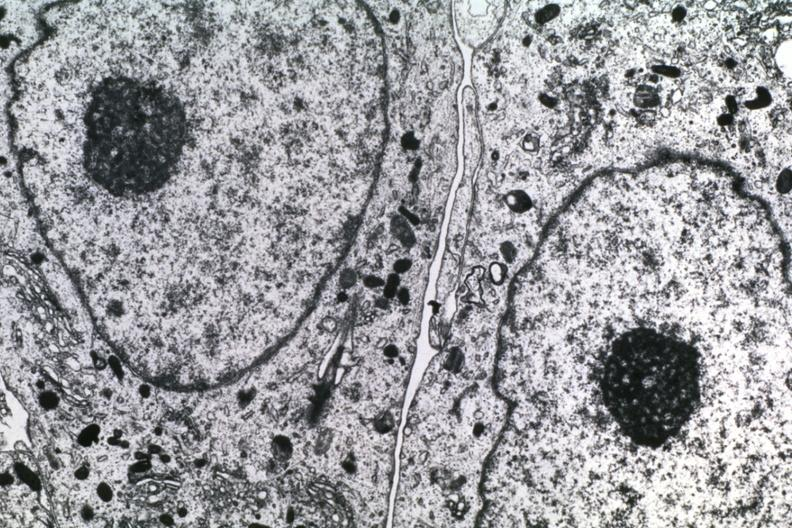s this typical lesion present?
Answer the question using a single word or phrase. No 